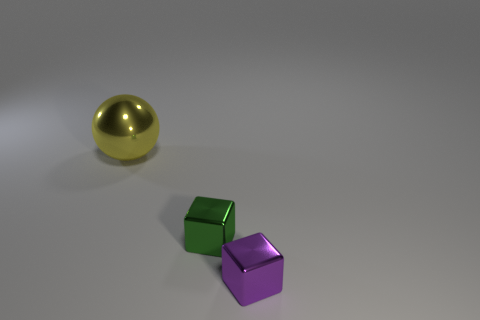How many small purple blocks are in front of the metal thing to the left of the green object?
Make the answer very short. 1. Is the shape of the small purple object the same as the small green shiny object?
Offer a very short reply. Yes. What is the shape of the big thing behind the thing that is to the right of the small green shiny thing?
Your answer should be very brief. Sphere. The yellow sphere has what size?
Provide a short and direct response. Large. The purple object is what shape?
Ensure brevity in your answer.  Cube. Does the purple thing have the same shape as the tiny metal thing that is behind the purple metal thing?
Your response must be concise. Yes. There is a metal thing right of the green cube; does it have the same shape as the green thing?
Your answer should be very brief. Yes. How many objects are to the left of the tiny purple block and in front of the large thing?
Provide a short and direct response. 1. What number of other objects are there of the same size as the green block?
Your response must be concise. 1. Is the number of blocks that are to the right of the green metallic thing the same as the number of yellow rubber objects?
Give a very brief answer. No. 